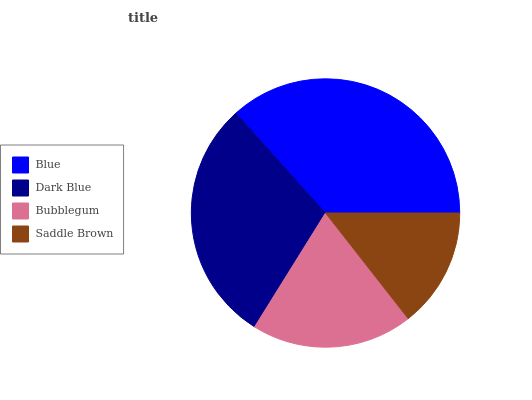Is Saddle Brown the minimum?
Answer yes or no. Yes. Is Blue the maximum?
Answer yes or no. Yes. Is Dark Blue the minimum?
Answer yes or no. No. Is Dark Blue the maximum?
Answer yes or no. No. Is Blue greater than Dark Blue?
Answer yes or no. Yes. Is Dark Blue less than Blue?
Answer yes or no. Yes. Is Dark Blue greater than Blue?
Answer yes or no. No. Is Blue less than Dark Blue?
Answer yes or no. No. Is Dark Blue the high median?
Answer yes or no. Yes. Is Bubblegum the low median?
Answer yes or no. Yes. Is Saddle Brown the high median?
Answer yes or no. No. Is Saddle Brown the low median?
Answer yes or no. No. 